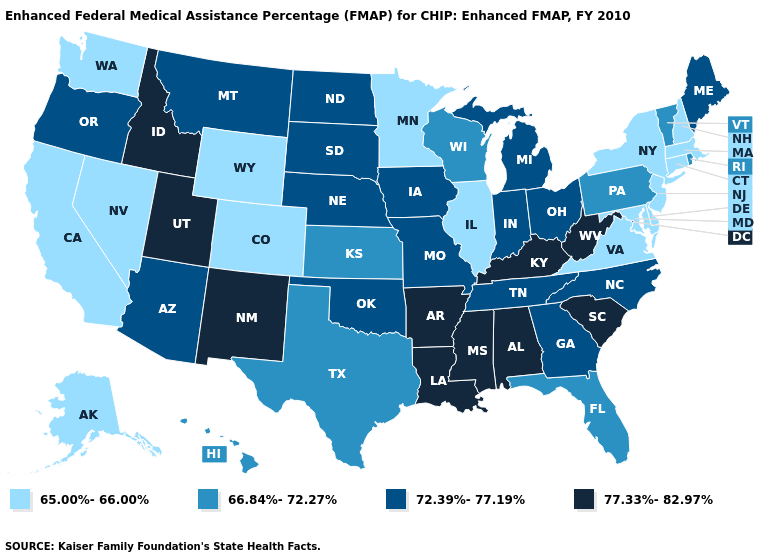Name the states that have a value in the range 77.33%-82.97%?
Be succinct. Alabama, Arkansas, Idaho, Kentucky, Louisiana, Mississippi, New Mexico, South Carolina, Utah, West Virginia. What is the value of South Carolina?
Short answer required. 77.33%-82.97%. Does Florida have a lower value than Connecticut?
Concise answer only. No. What is the value of Nebraska?
Answer briefly. 72.39%-77.19%. Does Vermont have the same value as Arizona?
Write a very short answer. No. Name the states that have a value in the range 65.00%-66.00%?
Concise answer only. Alaska, California, Colorado, Connecticut, Delaware, Illinois, Maryland, Massachusetts, Minnesota, Nevada, New Hampshire, New Jersey, New York, Virginia, Washington, Wyoming. Name the states that have a value in the range 72.39%-77.19%?
Concise answer only. Arizona, Georgia, Indiana, Iowa, Maine, Michigan, Missouri, Montana, Nebraska, North Carolina, North Dakota, Ohio, Oklahoma, Oregon, South Dakota, Tennessee. What is the value of Pennsylvania?
Answer briefly. 66.84%-72.27%. Does Illinois have the lowest value in the MidWest?
Write a very short answer. Yes. Among the states that border Ohio , does Pennsylvania have the lowest value?
Write a very short answer. Yes. What is the value of South Carolina?
Give a very brief answer. 77.33%-82.97%. Name the states that have a value in the range 66.84%-72.27%?
Short answer required. Florida, Hawaii, Kansas, Pennsylvania, Rhode Island, Texas, Vermont, Wisconsin. Among the states that border Washington , which have the highest value?
Quick response, please. Idaho. Does Indiana have a higher value than West Virginia?
Write a very short answer. No. Name the states that have a value in the range 65.00%-66.00%?
Answer briefly. Alaska, California, Colorado, Connecticut, Delaware, Illinois, Maryland, Massachusetts, Minnesota, Nevada, New Hampshire, New Jersey, New York, Virginia, Washington, Wyoming. 